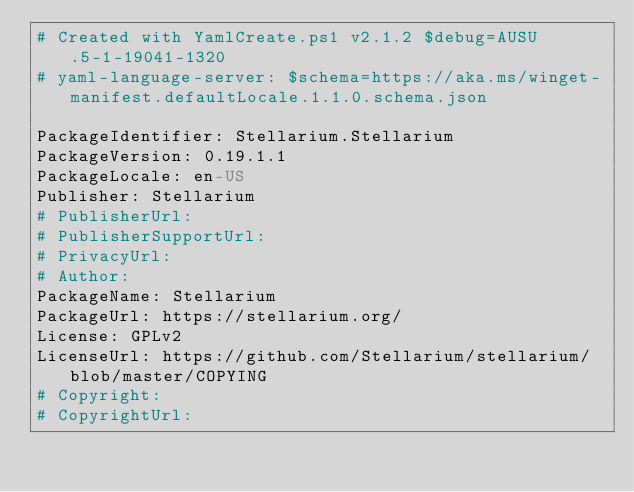<code> <loc_0><loc_0><loc_500><loc_500><_YAML_># Created with YamlCreate.ps1 v2.1.2 $debug=AUSU.5-1-19041-1320
# yaml-language-server: $schema=https://aka.ms/winget-manifest.defaultLocale.1.1.0.schema.json

PackageIdentifier: Stellarium.Stellarium
PackageVersion: 0.19.1.1
PackageLocale: en-US
Publisher: Stellarium
# PublisherUrl: 
# PublisherSupportUrl: 
# PrivacyUrl: 
# Author: 
PackageName: Stellarium
PackageUrl: https://stellarium.org/
License: GPLv2
LicenseUrl: https://github.com/Stellarium/stellarium/blob/master/COPYING
# Copyright: 
# CopyrightUrl: </code> 